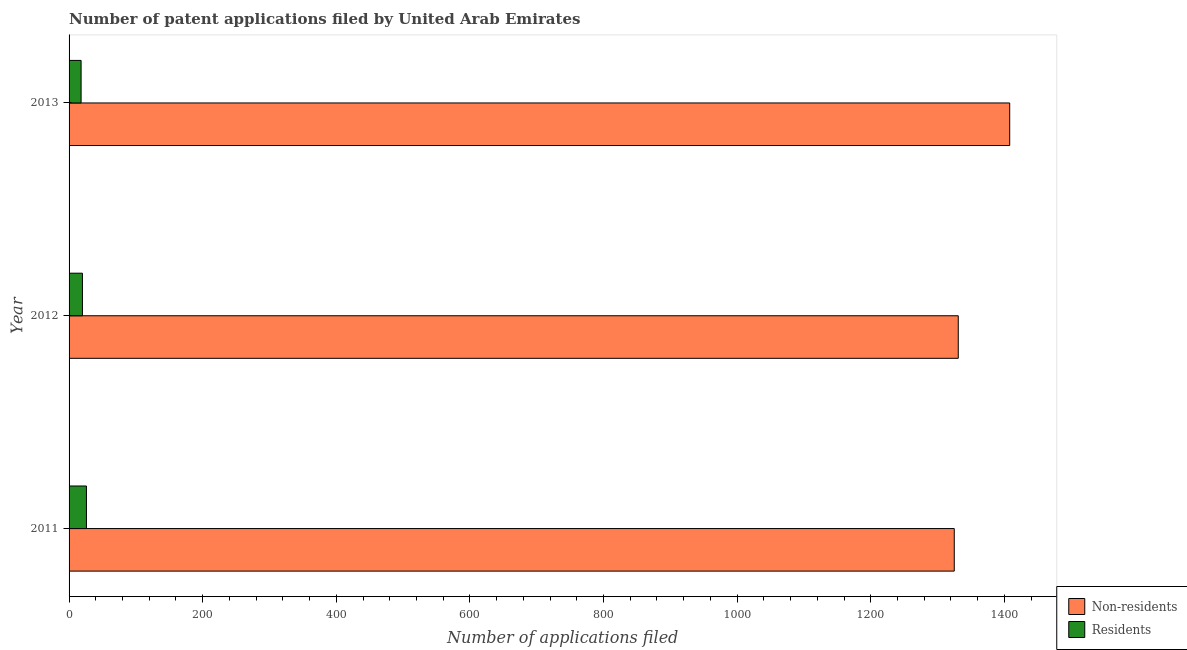How many groups of bars are there?
Your answer should be compact. 3. Are the number of bars on each tick of the Y-axis equal?
Your answer should be compact. Yes. How many bars are there on the 1st tick from the bottom?
Your answer should be very brief. 2. In how many cases, is the number of bars for a given year not equal to the number of legend labels?
Ensure brevity in your answer.  0. What is the number of patent applications by non residents in 2011?
Your response must be concise. 1325. Across all years, what is the maximum number of patent applications by non residents?
Offer a terse response. 1408. Across all years, what is the minimum number of patent applications by residents?
Keep it short and to the point. 18. In which year was the number of patent applications by non residents maximum?
Offer a very short reply. 2013. In which year was the number of patent applications by non residents minimum?
Keep it short and to the point. 2011. What is the total number of patent applications by non residents in the graph?
Provide a short and direct response. 4064. What is the difference between the number of patent applications by residents in 2012 and that in 2013?
Ensure brevity in your answer.  2. What is the difference between the number of patent applications by residents in 2012 and the number of patent applications by non residents in 2013?
Your response must be concise. -1388. What is the average number of patent applications by residents per year?
Give a very brief answer. 21.33. In the year 2013, what is the difference between the number of patent applications by non residents and number of patent applications by residents?
Your response must be concise. 1390. In how many years, is the number of patent applications by residents greater than 1000 ?
Offer a terse response. 0. What is the ratio of the number of patent applications by non residents in 2012 to that in 2013?
Give a very brief answer. 0.94. What is the difference between the highest and the lowest number of patent applications by residents?
Offer a terse response. 8. Is the sum of the number of patent applications by residents in 2012 and 2013 greater than the maximum number of patent applications by non residents across all years?
Offer a very short reply. No. What does the 1st bar from the top in 2011 represents?
Your answer should be very brief. Residents. What does the 2nd bar from the bottom in 2011 represents?
Offer a terse response. Residents. How many bars are there?
Your answer should be very brief. 6. Are all the bars in the graph horizontal?
Provide a short and direct response. Yes. Where does the legend appear in the graph?
Provide a short and direct response. Bottom right. What is the title of the graph?
Your answer should be compact. Number of patent applications filed by United Arab Emirates. Does "Foreign Liabilities" appear as one of the legend labels in the graph?
Provide a succinct answer. No. What is the label or title of the X-axis?
Offer a very short reply. Number of applications filed. What is the Number of applications filed of Non-residents in 2011?
Give a very brief answer. 1325. What is the Number of applications filed of Non-residents in 2012?
Offer a very short reply. 1331. What is the Number of applications filed of Non-residents in 2013?
Offer a very short reply. 1408. What is the Number of applications filed in Residents in 2013?
Your answer should be compact. 18. Across all years, what is the maximum Number of applications filed in Non-residents?
Make the answer very short. 1408. Across all years, what is the minimum Number of applications filed in Non-residents?
Your answer should be very brief. 1325. What is the total Number of applications filed in Non-residents in the graph?
Make the answer very short. 4064. What is the difference between the Number of applications filed of Residents in 2011 and that in 2012?
Give a very brief answer. 6. What is the difference between the Number of applications filed of Non-residents in 2011 and that in 2013?
Your answer should be compact. -83. What is the difference between the Number of applications filed in Non-residents in 2012 and that in 2013?
Offer a terse response. -77. What is the difference between the Number of applications filed in Non-residents in 2011 and the Number of applications filed in Residents in 2012?
Offer a terse response. 1305. What is the difference between the Number of applications filed of Non-residents in 2011 and the Number of applications filed of Residents in 2013?
Make the answer very short. 1307. What is the difference between the Number of applications filed of Non-residents in 2012 and the Number of applications filed of Residents in 2013?
Your response must be concise. 1313. What is the average Number of applications filed in Non-residents per year?
Offer a very short reply. 1354.67. What is the average Number of applications filed of Residents per year?
Your answer should be very brief. 21.33. In the year 2011, what is the difference between the Number of applications filed of Non-residents and Number of applications filed of Residents?
Give a very brief answer. 1299. In the year 2012, what is the difference between the Number of applications filed of Non-residents and Number of applications filed of Residents?
Offer a very short reply. 1311. In the year 2013, what is the difference between the Number of applications filed of Non-residents and Number of applications filed of Residents?
Your response must be concise. 1390. What is the ratio of the Number of applications filed of Non-residents in 2011 to that in 2013?
Your response must be concise. 0.94. What is the ratio of the Number of applications filed of Residents in 2011 to that in 2013?
Offer a terse response. 1.44. What is the ratio of the Number of applications filed in Non-residents in 2012 to that in 2013?
Keep it short and to the point. 0.95. What is the ratio of the Number of applications filed in Residents in 2012 to that in 2013?
Ensure brevity in your answer.  1.11. 